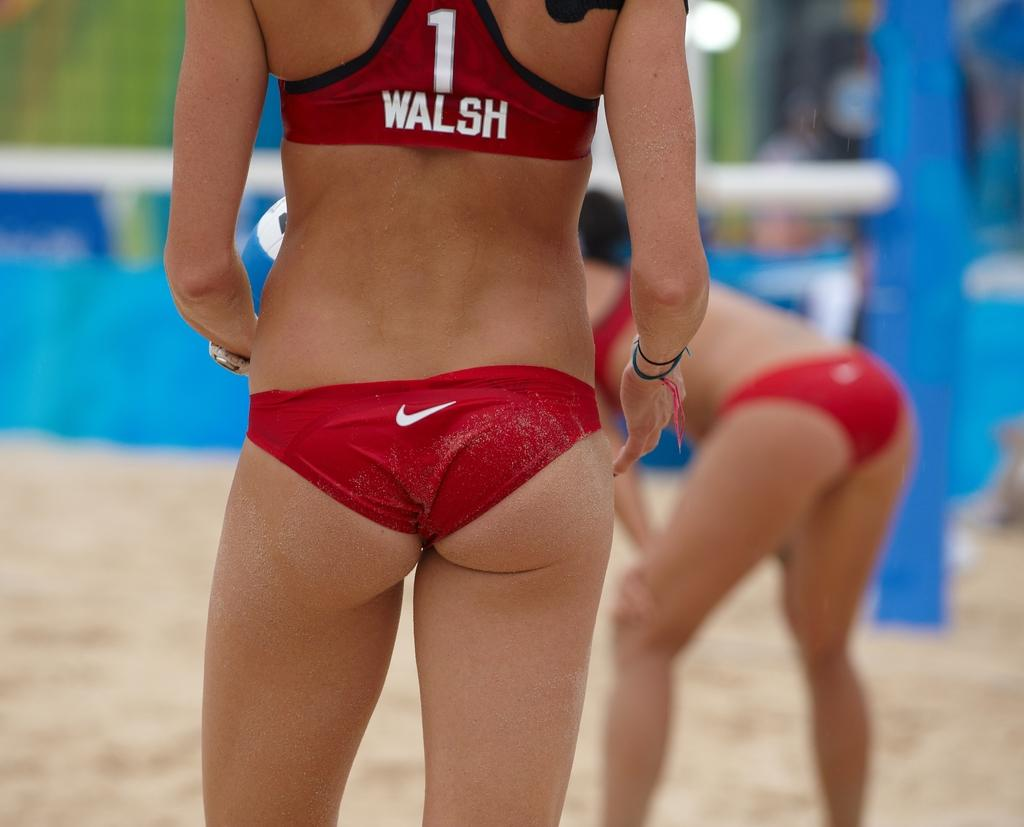<image>
Share a concise interpretation of the image provided. a girl that has the name Walsh on the back of her shirt 